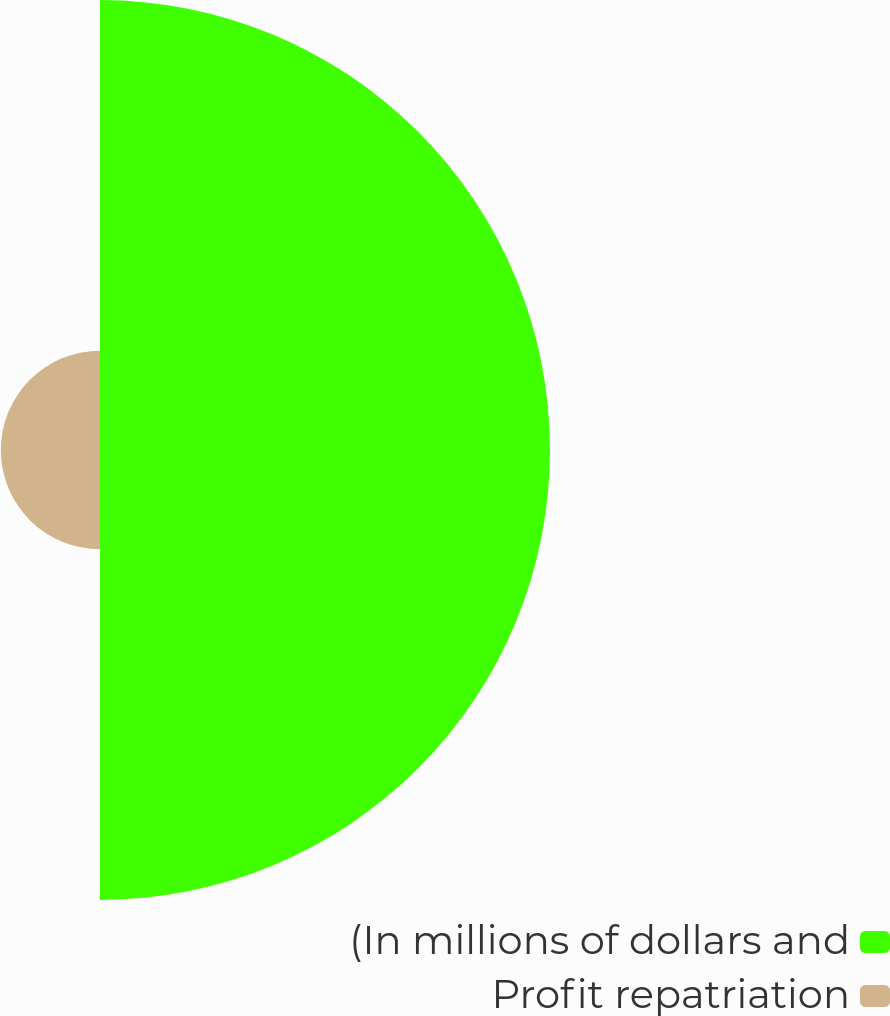Convert chart. <chart><loc_0><loc_0><loc_500><loc_500><pie_chart><fcel>(In millions of dollars and<fcel>Profit repatriation<nl><fcel>81.94%<fcel>18.06%<nl></chart> 